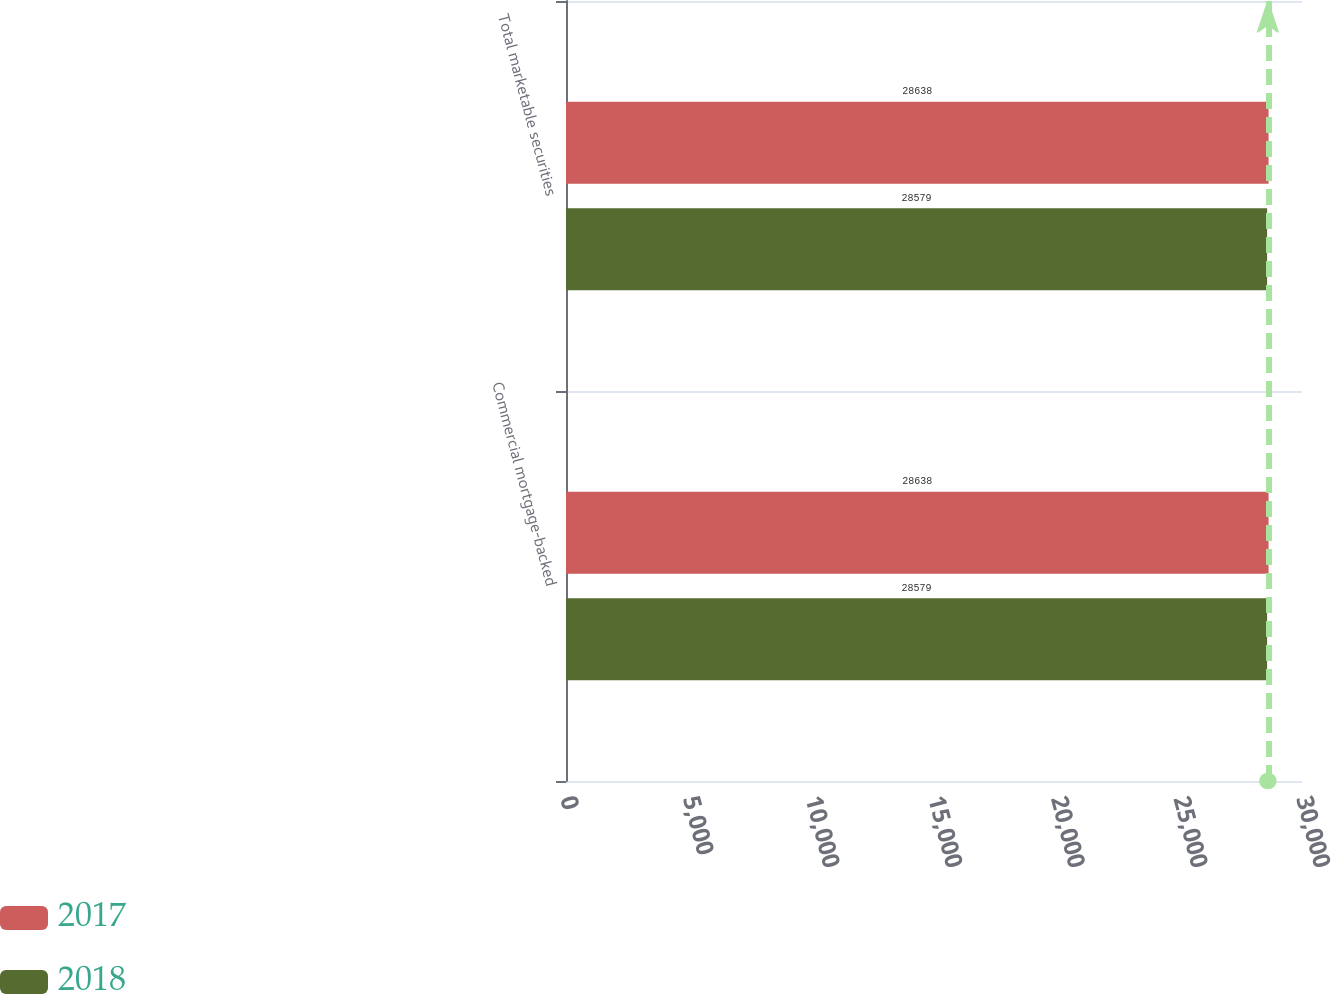<chart> <loc_0><loc_0><loc_500><loc_500><stacked_bar_chart><ecel><fcel>Commercial mortgage-backed<fcel>Total marketable securities<nl><fcel>2017<fcel>28638<fcel>28638<nl><fcel>2018<fcel>28579<fcel>28579<nl></chart> 